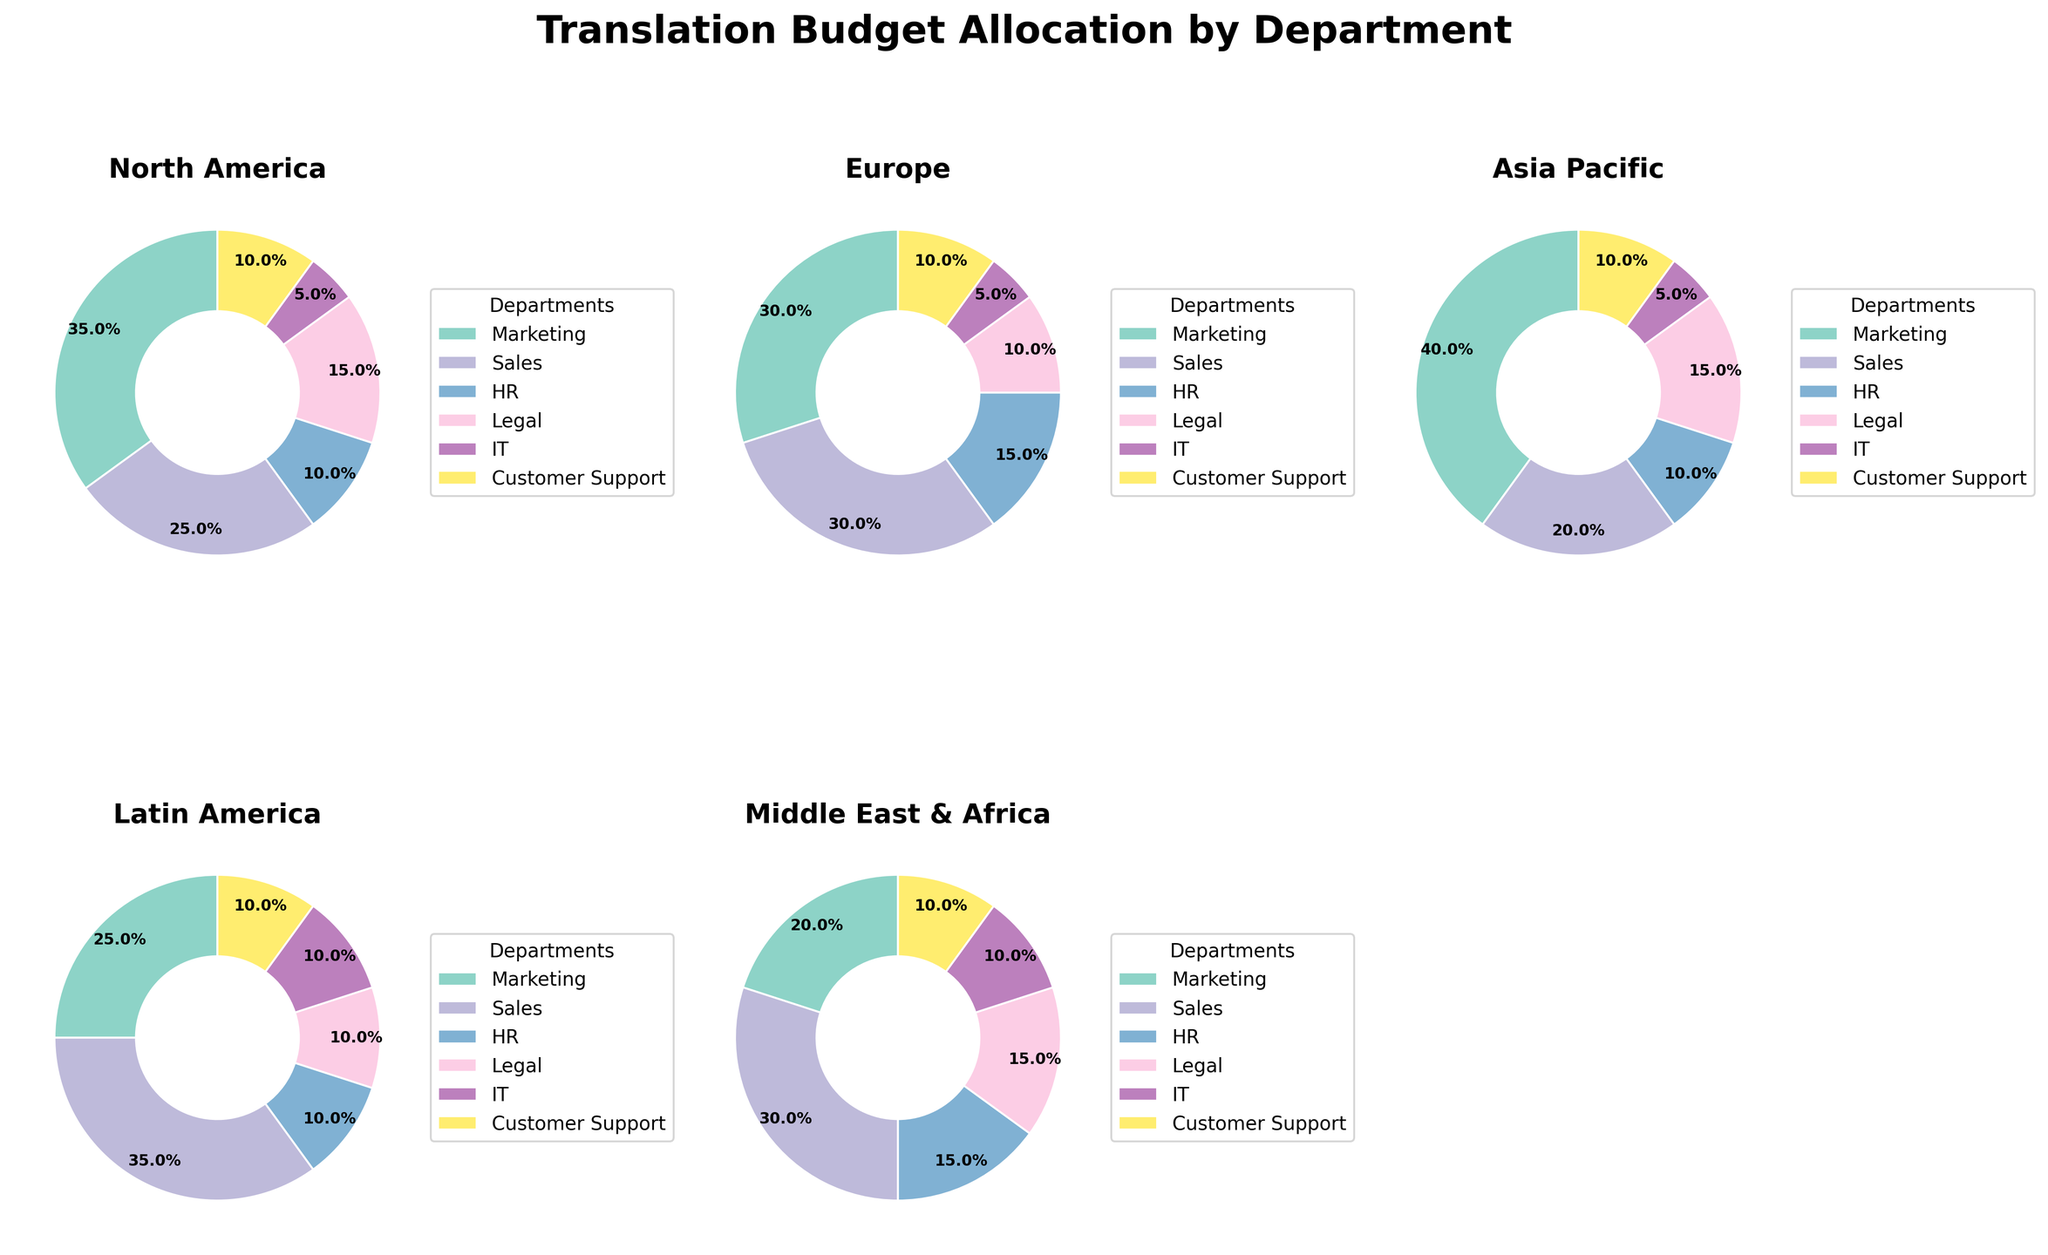Which department has the highest budget allocation for North America? For North America, the pie chart shows that the Marketing department has the largest wedge.
Answer: Marketing Which region has the largest budget allocation for the Sales department? By looking at each pie chart, the Sales department has the largest wedge for the Latin America region.
Answer: Latin America What is the total budget allocation percentage for the HR and Legal departments in Europe? In the Europe pie chart, the HR and Legal department allocations are 15% and 10% respectively. Adding these gives 15% + 10% = 25%.
Answer: 25% Compare the budget allocation for IT department in North America and Asia Pacific. Which region has a greater percentage? The IT department allocation is 5% in North America and 5% in Asia Pacific, making them equal.
Answer: Equal What is the smallest department allocation across all regions? By inspecting all the pie charts, for each region, the IT department consistently has the smallest allocation of 5%.
Answer: IT How much greater is the Marketing budget allocation in Asia Pacific compared to Europe? The Marketing budget allocation in Asia Pacific is 40%, and in Europe, it is 30%. The difference is 40% - 30% = 10%.
Answer: 10% What’s the average budget allocation for Customer Support across all regions? Summing up the Customer Support allocations from each region: 10% + 10% + 10% + 10% + 10% = 50%. Dividing 50% by the 5 regions gives 50% / 5 = 10%.
Answer: 10% Which region has the most balanced budget allocation among departments (i.e., the smallest variance in proportions)? Looking at the pie charts, Latin America has the most balanced allocation, with percentages close to each other: 25%, 35%, 10%, 10%, 10%, 10%.
Answer: Latin America 